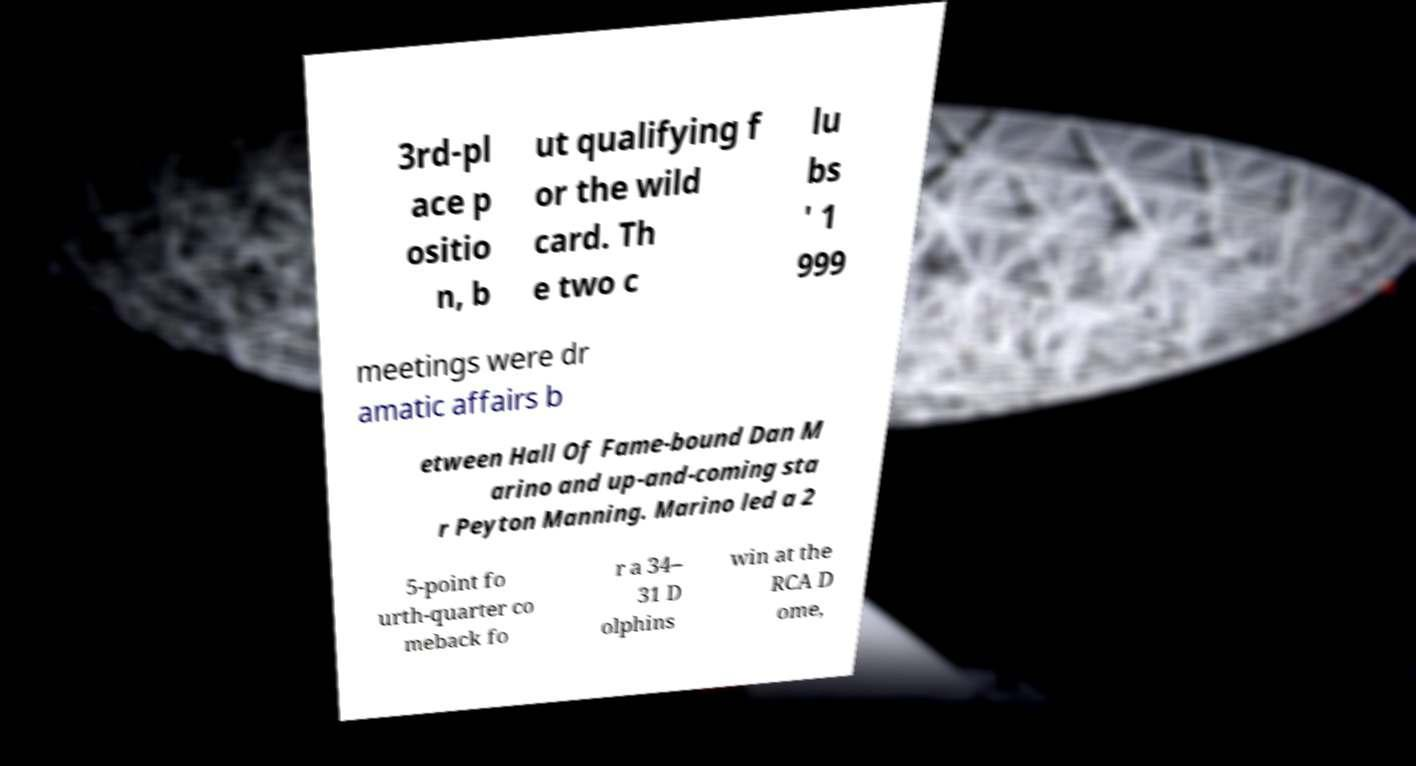There's text embedded in this image that I need extracted. Can you transcribe it verbatim? 3rd-pl ace p ositio n, b ut qualifying f or the wild card. Th e two c lu bs ' 1 999 meetings were dr amatic affairs b etween Hall Of Fame-bound Dan M arino and up-and-coming sta r Peyton Manning. Marino led a 2 5-point fo urth-quarter co meback fo r a 34– 31 D olphins win at the RCA D ome, 